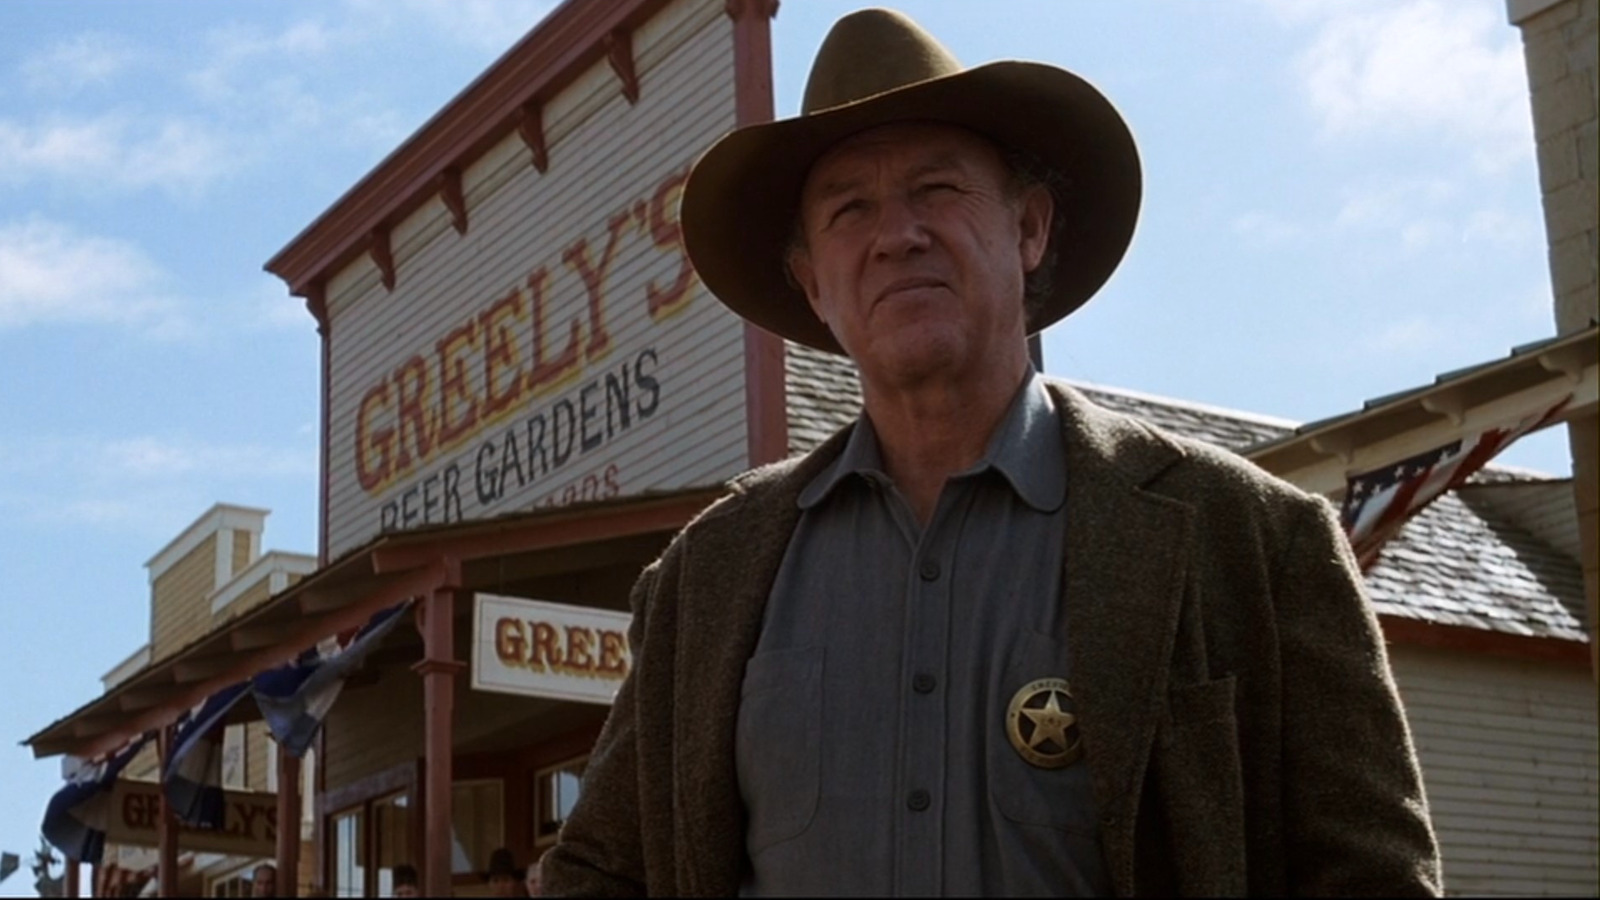Can you tell me more about the setting in which this person is standing? The individual is standing in front of a two-story building with a sign that says 'Greenly's Beer Gardens.' The architecture has a historical aesthetic with characteristics that could place it in a setting that mimics a town from the late 19th or early 20th century. The presence of American flags suggests a setting within the United States. This could be a part of a larger historical recreation or an outdoor event dedicated to representing a certain era. 